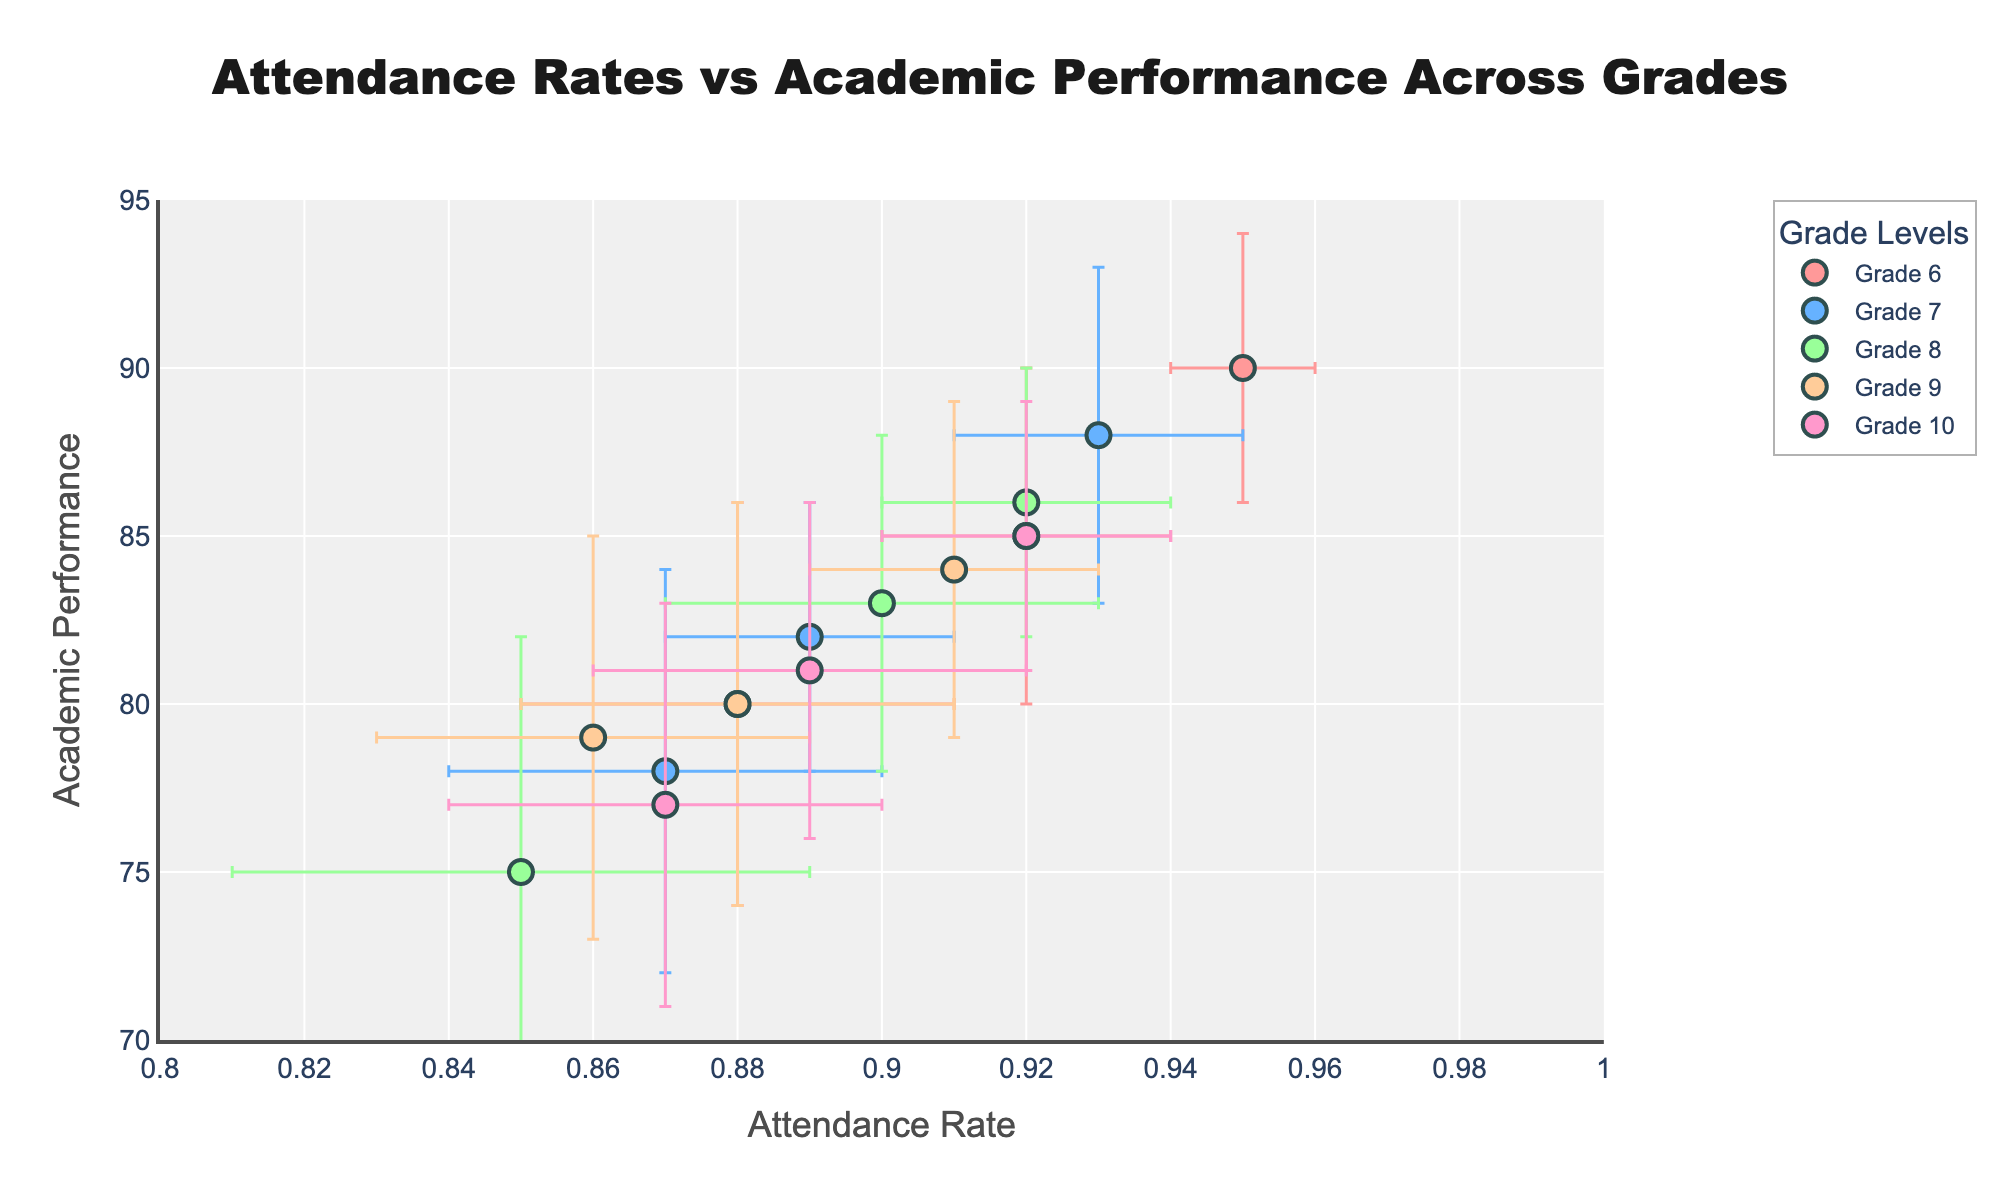what is the title of the figure? The title of the figure is positioned at the top center. By reading, we find it's "Attendance Rates vs Academic Performance Across Grades"
Answer: Attendance Rates vs Academic Performance Across Grades What are the two axes in the figure labeled as? The x-axis is labeled as "Attendance Rate" and the y-axis is labeled as "Academic Performance." This can be observed directly from the axis titles in the figure.
Answer: Attendance Rate and Academic Performance How many grades are represented in the figure? Each grade is represented by a different color and legend entry. By counting the legend entries, we find that there are five grades represented: 6, 7, 8, 9, and 10.
Answer: Five What is the range of attendance rates shown? The x-axis has its range set between 0.8 and 1, as indicated by the axis limits.
Answer: 0.8 to 1 In which grade is the highest recorded academic performance observed, and what is the value? By examining the scatter points, we notice the highest academic performance (90) is recorded in grade 6. This can be observed by looking for the maximum y-coordinate among the points for each grade.
Answer: Grade 6, 90 Which grade has the most variation in academic performance? The variation in academic performance can be inferred from the error bars. By comparing the lengths of the vertical error bars for each grade, we see that grade 8 has the widest error bars, indicating the most variation.
Answer: Grade 8 Is there any grade where all data points have attendance rates above 0.90? By inspecting each scatter point and their corresponding attendance rates for each grade, we find that grade 6 has all points with attendance rates above 0.90.
Answer: Grade 6 What's the lowest attendance rate observed in grade 8? By looking at the x-coordinates of the scatter points for grade 8, we find the lowest attendance rate which is 0.85.
Answer: 0.85 Which grade has a data point with the lowest academic performance, and what is the value? By surveying the scatter points for the lowest y-coordinate, we find the lowest academic performance value is 75, which is observed in grade 8.
Answer: Grade 8, 75 How does the academic performance generally trend with increasing attendance rate for grades 8 and 9? For these grades, grade 9 shows a more consistent trend where academic performance increases with attendance rate. In grade 8, the trend is less clear as the data points show more variation.
Answer: Grade 9 shows a more consistent increasing trend 